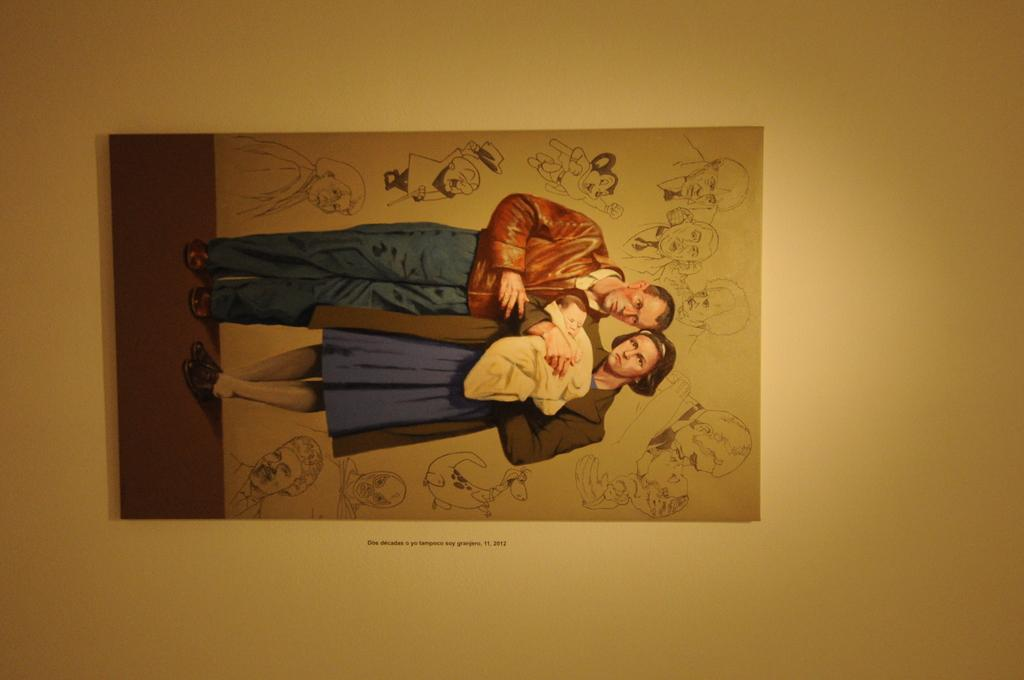What is hanging on the wall in the image? There is a photo on the wall in the image. Who or what is depicted in the photo? The photo contains two people, one of whom is holding a baby. What else can be seen in the photo besides the people? There are sketches around the people in the photo. What type of authority is depicted in the photo? There is no authority figure depicted in the photo; it features two people and a baby. How does the self-awareness of the baby in the photo manifest? The photo does not show the baby's self-awareness; it is a still image. 